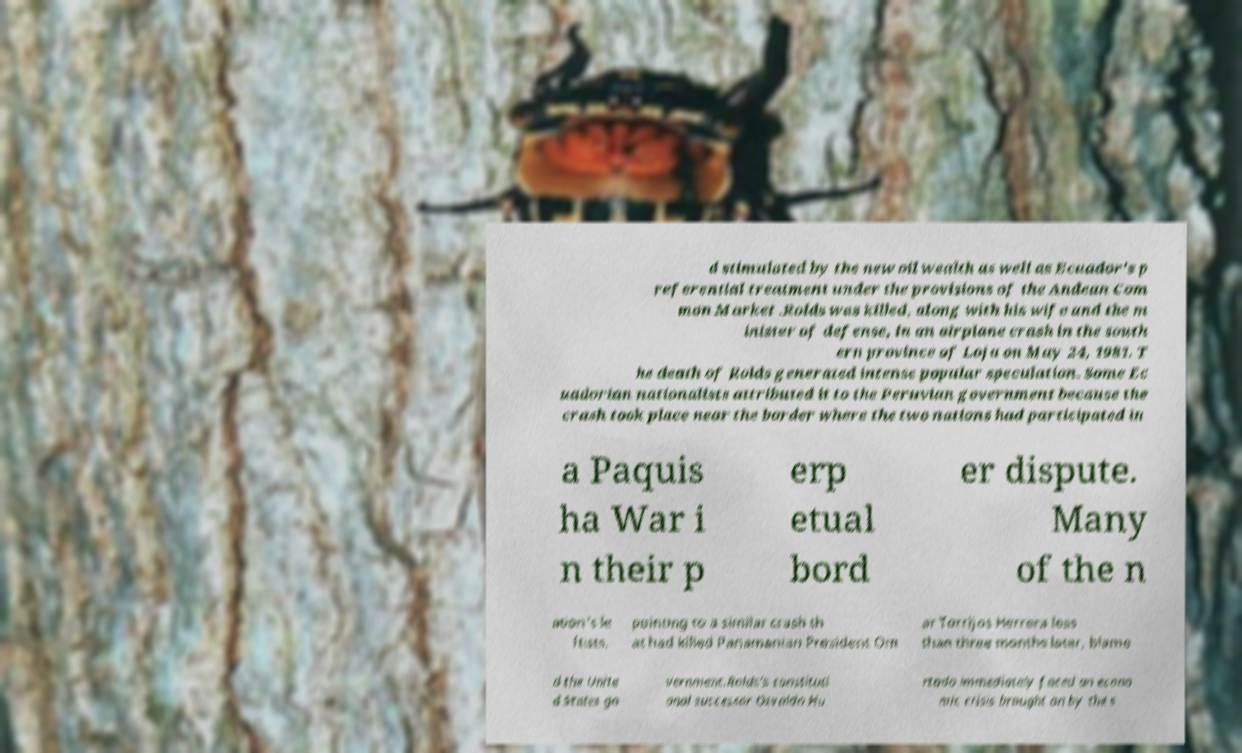Could you extract and type out the text from this image? d stimulated by the new oil wealth as well as Ecuador's p referential treatment under the provisions of the Andean Com mon Market .Rolds was killed, along with his wife and the m inister of defense, in an airplane crash in the south ern province of Loja on May 24, 1981. T he death of Rolds generated intense popular speculation. Some Ec uadorian nationalists attributed it to the Peruvian government because the crash took place near the border where the two nations had participated in a Paquis ha War i n their p erp etual bord er dispute. Many of the n ation's le ftists, pointing to a similar crash th at had killed Panamanian President Om ar Torrijos Herrera less than three months later, blame d the Unite d States go vernment.Rolds's constituti onal successor Osvaldo Hu rtado immediately faced an econo mic crisis brought on by the s 